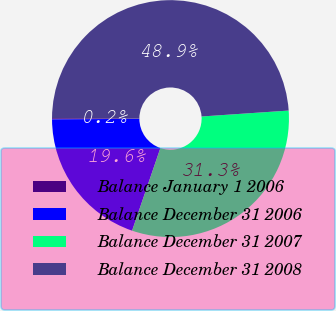Convert chart to OTSL. <chart><loc_0><loc_0><loc_500><loc_500><pie_chart><fcel>Balance January 1 2006<fcel>Balance December 31 2006<fcel>Balance December 31 2007<fcel>Balance December 31 2008<nl><fcel>0.16%<fcel>19.64%<fcel>31.33%<fcel>48.86%<nl></chart> 